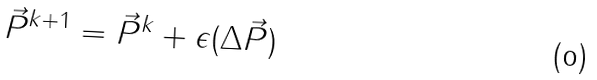<formula> <loc_0><loc_0><loc_500><loc_500>\vec { P } ^ { k + 1 } = \vec { P } ^ { k } + \epsilon ( \Delta \vec { P } )</formula> 